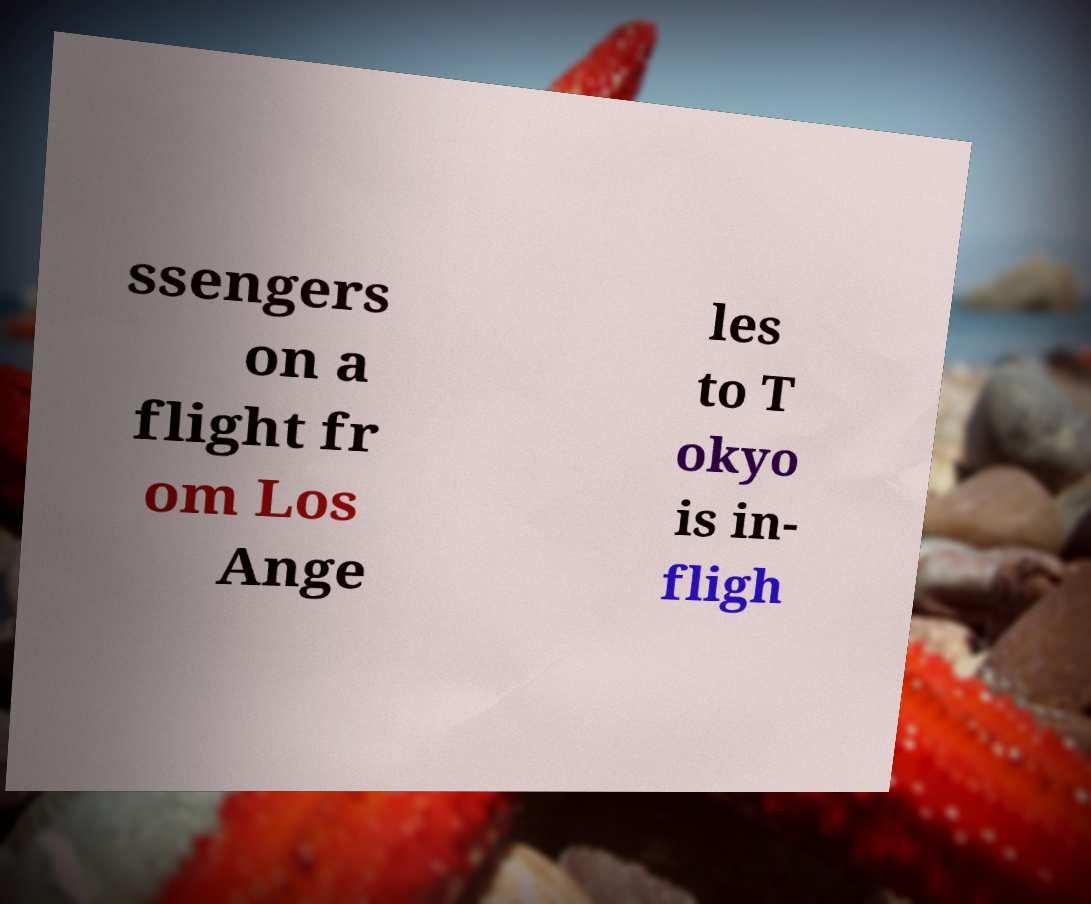I need the written content from this picture converted into text. Can you do that? ssengers on a flight fr om Los Ange les to T okyo is in- fligh 